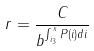<formula> <loc_0><loc_0><loc_500><loc_500>r = \frac { C } { b ^ { \int _ { i _ { 3 } } ^ { x } P ( i ) d i } }</formula> 